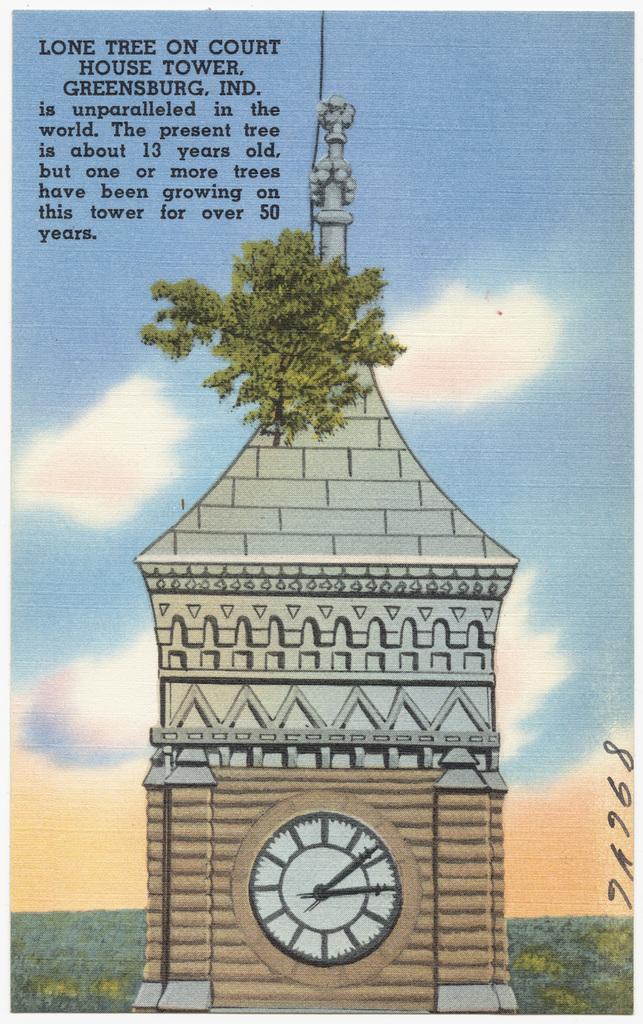Describe this image in one or two sentences. In this image I can see the clock tower, background I can see the plant in green color and the sky is in blue and white color and I can see something written on the image. 